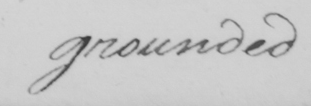What text is written in this handwritten line? grounded 